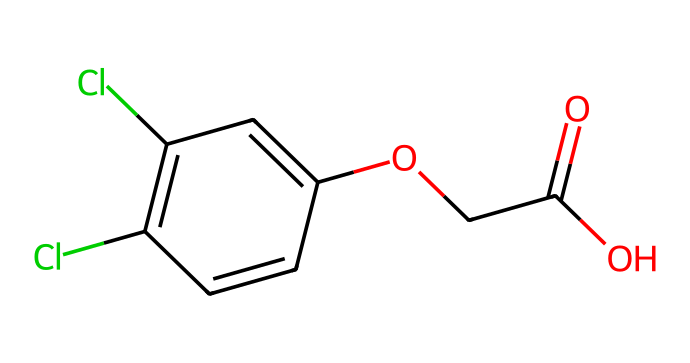What is the main functional group in 2,4-D? The chemical structure includes a carboxylic acid (-COOH) group evident from the presence of the carbon atom connected to an oxygen atom with a double bond (C=O) and a single bond to another oxygen atom (C-OH). This indicates the presence of a carboxylic acid functional group.
Answer: carboxylic acid How many chlorine atoms are present in 2,4-D? By analyzing the chemical structure represented in the SMILES, we can see two chlorine (Cl) atoms attached to the aromatic ring. Therefore, the count of chlorine atoms can be directly observed.
Answer: two What type of herbicide classification does 2,4-D belong to? The structure contains a phenoxy acid group, which classifies it specifically under phenoxy herbicides, known for their use in controlling broadleaf weeds effectively.
Answer: phenoxy What is the total number of aromatic rings in 2,4-D? Observing the structure, the main undulating arrangement of carbon and associated substituents indicates that there is a single aromatic ring, which can be inferred from the alternating double bonds present.
Answer: one What is the molecular formula of 2,4-D? From the visual representation of the structure, we count the atoms: 8 carbon (C) atoms, 6 hydrogen (H) atoms, 2 chlorine (Cl) atoms, and 4 oxygen (O) atoms, giving the complete molecular formula as C8H6Cl2O3.
Answer: C8H6Cl2O3 